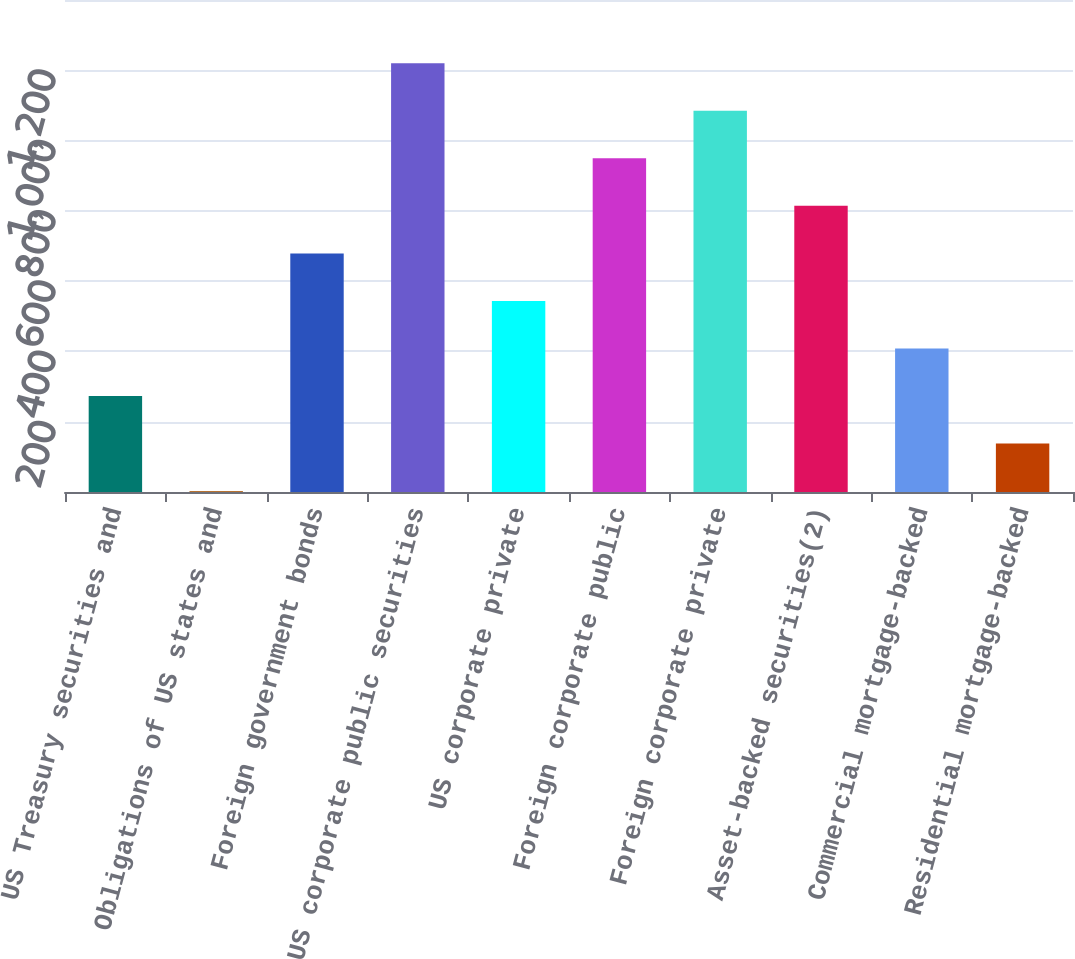Convert chart to OTSL. <chart><loc_0><loc_0><loc_500><loc_500><bar_chart><fcel>US Treasury securities and<fcel>Obligations of US states and<fcel>Foreign government bonds<fcel>US corporate public securities<fcel>US corporate private<fcel>Foreign corporate public<fcel>Foreign corporate private<fcel>Asset-backed securities(2)<fcel>Commercial mortgage-backed<fcel>Residential mortgage-backed<nl><fcel>273.4<fcel>3<fcel>679<fcel>1219.8<fcel>543.8<fcel>949.4<fcel>1084.6<fcel>814.2<fcel>408.6<fcel>138.2<nl></chart> 